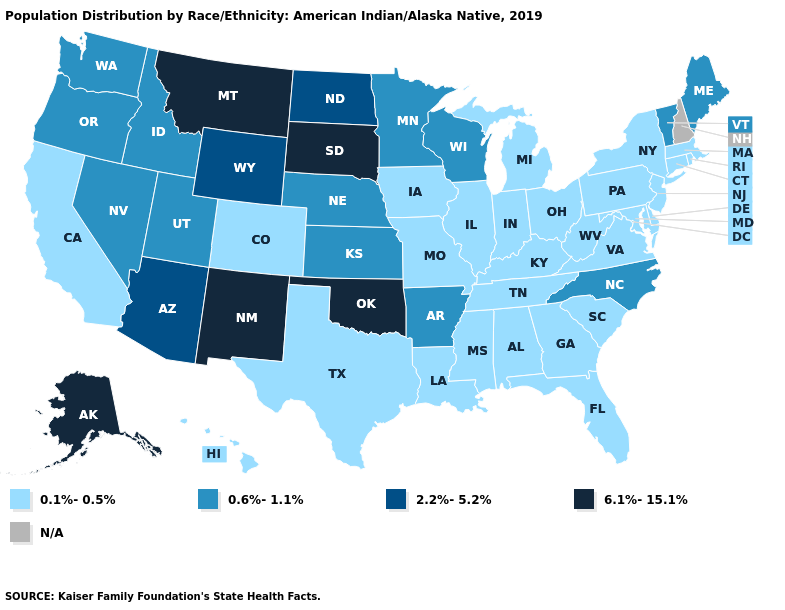What is the value of California?
Write a very short answer. 0.1%-0.5%. Which states have the lowest value in the MidWest?
Short answer required. Illinois, Indiana, Iowa, Michigan, Missouri, Ohio. Does the first symbol in the legend represent the smallest category?
Keep it brief. Yes. Which states have the lowest value in the MidWest?
Answer briefly. Illinois, Indiana, Iowa, Michigan, Missouri, Ohio. Among the states that border Nebraska , does Iowa have the lowest value?
Be succinct. Yes. How many symbols are there in the legend?
Concise answer only. 5. Name the states that have a value in the range 0.1%-0.5%?
Keep it brief. Alabama, California, Colorado, Connecticut, Delaware, Florida, Georgia, Hawaii, Illinois, Indiana, Iowa, Kentucky, Louisiana, Maryland, Massachusetts, Michigan, Mississippi, Missouri, New Jersey, New York, Ohio, Pennsylvania, Rhode Island, South Carolina, Tennessee, Texas, Virginia, West Virginia. Among the states that border Virginia , does Tennessee have the highest value?
Keep it brief. No. Which states have the highest value in the USA?
Short answer required. Alaska, Montana, New Mexico, Oklahoma, South Dakota. Which states have the lowest value in the USA?
Quick response, please. Alabama, California, Colorado, Connecticut, Delaware, Florida, Georgia, Hawaii, Illinois, Indiana, Iowa, Kentucky, Louisiana, Maryland, Massachusetts, Michigan, Mississippi, Missouri, New Jersey, New York, Ohio, Pennsylvania, Rhode Island, South Carolina, Tennessee, Texas, Virginia, West Virginia. How many symbols are there in the legend?
Keep it brief. 5. Does Oregon have the lowest value in the West?
Keep it brief. No. What is the lowest value in the USA?
Keep it brief. 0.1%-0.5%. 